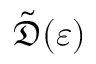<formula> <loc_0><loc_0><loc_500><loc_500>\tilde { \mathfrak { D } } ( \varepsilon )</formula> 